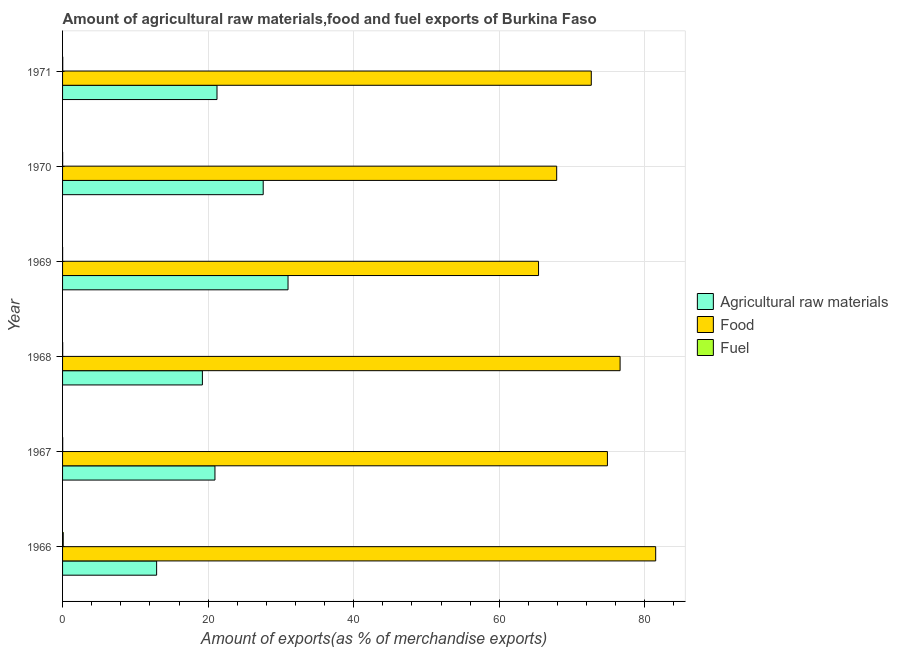How many different coloured bars are there?
Give a very brief answer. 3. How many groups of bars are there?
Your answer should be very brief. 6. How many bars are there on the 6th tick from the top?
Give a very brief answer. 3. How many bars are there on the 4th tick from the bottom?
Make the answer very short. 3. What is the label of the 3rd group of bars from the top?
Provide a succinct answer. 1969. In how many cases, is the number of bars for a given year not equal to the number of legend labels?
Ensure brevity in your answer.  0. What is the percentage of food exports in 1969?
Your response must be concise. 65.39. Across all years, what is the maximum percentage of food exports?
Your answer should be compact. 81.49. Across all years, what is the minimum percentage of fuel exports?
Ensure brevity in your answer.  0.01. In which year was the percentage of raw materials exports maximum?
Your answer should be very brief. 1969. In which year was the percentage of raw materials exports minimum?
Provide a short and direct response. 1966. What is the total percentage of raw materials exports in the graph?
Offer a very short reply. 132.83. What is the difference between the percentage of food exports in 1967 and that in 1969?
Your response must be concise. 9.46. What is the difference between the percentage of fuel exports in 1966 and the percentage of raw materials exports in 1971?
Offer a terse response. -21.13. What is the average percentage of fuel exports per year?
Offer a very short reply. 0.03. In the year 1967, what is the difference between the percentage of fuel exports and percentage of food exports?
Offer a very short reply. -74.84. What is the ratio of the percentage of raw materials exports in 1967 to that in 1968?
Your response must be concise. 1.09. Is the difference between the percentage of fuel exports in 1968 and 1971 greater than the difference between the percentage of food exports in 1968 and 1971?
Offer a very short reply. No. What is the difference between the highest and the second highest percentage of food exports?
Ensure brevity in your answer.  4.89. What is the difference between the highest and the lowest percentage of fuel exports?
Offer a terse response. 0.08. In how many years, is the percentage of fuel exports greater than the average percentage of fuel exports taken over all years?
Make the answer very short. 1. Is the sum of the percentage of fuel exports in 1966 and 1967 greater than the maximum percentage of raw materials exports across all years?
Ensure brevity in your answer.  No. What does the 2nd bar from the top in 1967 represents?
Offer a very short reply. Food. What does the 1st bar from the bottom in 1968 represents?
Provide a succinct answer. Agricultural raw materials. How many years are there in the graph?
Offer a terse response. 6. Does the graph contain any zero values?
Keep it short and to the point. No. Does the graph contain grids?
Offer a very short reply. Yes. Where does the legend appear in the graph?
Offer a terse response. Center right. How many legend labels are there?
Your response must be concise. 3. What is the title of the graph?
Offer a very short reply. Amount of agricultural raw materials,food and fuel exports of Burkina Faso. Does "Ores and metals" appear as one of the legend labels in the graph?
Make the answer very short. No. What is the label or title of the X-axis?
Provide a short and direct response. Amount of exports(as % of merchandise exports). What is the label or title of the Y-axis?
Make the answer very short. Year. What is the Amount of exports(as % of merchandise exports) in Agricultural raw materials in 1966?
Make the answer very short. 12.92. What is the Amount of exports(as % of merchandise exports) of Food in 1966?
Your answer should be compact. 81.49. What is the Amount of exports(as % of merchandise exports) of Fuel in 1966?
Give a very brief answer. 0.09. What is the Amount of exports(as % of merchandise exports) of Agricultural raw materials in 1967?
Keep it short and to the point. 20.94. What is the Amount of exports(as % of merchandise exports) in Food in 1967?
Provide a short and direct response. 74.86. What is the Amount of exports(as % of merchandise exports) of Fuel in 1967?
Provide a succinct answer. 0.02. What is the Amount of exports(as % of merchandise exports) in Agricultural raw materials in 1968?
Ensure brevity in your answer.  19.21. What is the Amount of exports(as % of merchandise exports) in Food in 1968?
Offer a very short reply. 76.6. What is the Amount of exports(as % of merchandise exports) in Fuel in 1968?
Keep it short and to the point. 0.02. What is the Amount of exports(as % of merchandise exports) of Agricultural raw materials in 1969?
Your answer should be very brief. 30.98. What is the Amount of exports(as % of merchandise exports) in Food in 1969?
Provide a succinct answer. 65.39. What is the Amount of exports(as % of merchandise exports) in Fuel in 1969?
Make the answer very short. 0.01. What is the Amount of exports(as % of merchandise exports) of Agricultural raw materials in 1970?
Provide a short and direct response. 27.56. What is the Amount of exports(as % of merchandise exports) of Food in 1970?
Keep it short and to the point. 67.89. What is the Amount of exports(as % of merchandise exports) of Fuel in 1970?
Provide a succinct answer. 0.01. What is the Amount of exports(as % of merchandise exports) of Agricultural raw materials in 1971?
Ensure brevity in your answer.  21.22. What is the Amount of exports(as % of merchandise exports) in Food in 1971?
Give a very brief answer. 72.64. What is the Amount of exports(as % of merchandise exports) in Fuel in 1971?
Make the answer very short. 0.02. Across all years, what is the maximum Amount of exports(as % of merchandise exports) in Agricultural raw materials?
Give a very brief answer. 30.98. Across all years, what is the maximum Amount of exports(as % of merchandise exports) in Food?
Provide a short and direct response. 81.49. Across all years, what is the maximum Amount of exports(as % of merchandise exports) of Fuel?
Keep it short and to the point. 0.09. Across all years, what is the minimum Amount of exports(as % of merchandise exports) of Agricultural raw materials?
Provide a succinct answer. 12.92. Across all years, what is the minimum Amount of exports(as % of merchandise exports) in Food?
Your answer should be very brief. 65.39. Across all years, what is the minimum Amount of exports(as % of merchandise exports) in Fuel?
Offer a very short reply. 0.01. What is the total Amount of exports(as % of merchandise exports) in Agricultural raw materials in the graph?
Your answer should be compact. 132.83. What is the total Amount of exports(as % of merchandise exports) of Food in the graph?
Make the answer very short. 438.86. What is the total Amount of exports(as % of merchandise exports) of Fuel in the graph?
Your answer should be compact. 0.16. What is the difference between the Amount of exports(as % of merchandise exports) in Agricultural raw materials in 1966 and that in 1967?
Offer a terse response. -8.01. What is the difference between the Amount of exports(as % of merchandise exports) in Food in 1966 and that in 1967?
Keep it short and to the point. 6.63. What is the difference between the Amount of exports(as % of merchandise exports) in Fuel in 1966 and that in 1967?
Offer a very short reply. 0.07. What is the difference between the Amount of exports(as % of merchandise exports) of Agricultural raw materials in 1966 and that in 1968?
Give a very brief answer. -6.29. What is the difference between the Amount of exports(as % of merchandise exports) of Food in 1966 and that in 1968?
Give a very brief answer. 4.89. What is the difference between the Amount of exports(as % of merchandise exports) in Fuel in 1966 and that in 1968?
Your answer should be compact. 0.07. What is the difference between the Amount of exports(as % of merchandise exports) in Agricultural raw materials in 1966 and that in 1969?
Your answer should be compact. -18.05. What is the difference between the Amount of exports(as % of merchandise exports) of Food in 1966 and that in 1969?
Provide a succinct answer. 16.09. What is the difference between the Amount of exports(as % of merchandise exports) of Fuel in 1966 and that in 1969?
Make the answer very short. 0.08. What is the difference between the Amount of exports(as % of merchandise exports) in Agricultural raw materials in 1966 and that in 1970?
Provide a short and direct response. -14.64. What is the difference between the Amount of exports(as % of merchandise exports) in Food in 1966 and that in 1970?
Ensure brevity in your answer.  13.6. What is the difference between the Amount of exports(as % of merchandise exports) of Fuel in 1966 and that in 1970?
Give a very brief answer. 0.08. What is the difference between the Amount of exports(as % of merchandise exports) of Agricultural raw materials in 1966 and that in 1971?
Your answer should be very brief. -8.29. What is the difference between the Amount of exports(as % of merchandise exports) in Food in 1966 and that in 1971?
Keep it short and to the point. 8.85. What is the difference between the Amount of exports(as % of merchandise exports) in Fuel in 1966 and that in 1971?
Make the answer very short. 0.07. What is the difference between the Amount of exports(as % of merchandise exports) in Agricultural raw materials in 1967 and that in 1968?
Provide a short and direct response. 1.73. What is the difference between the Amount of exports(as % of merchandise exports) in Food in 1967 and that in 1968?
Offer a very short reply. -1.74. What is the difference between the Amount of exports(as % of merchandise exports) of Agricultural raw materials in 1967 and that in 1969?
Offer a very short reply. -10.04. What is the difference between the Amount of exports(as % of merchandise exports) of Food in 1967 and that in 1969?
Offer a terse response. 9.46. What is the difference between the Amount of exports(as % of merchandise exports) in Fuel in 1967 and that in 1969?
Your answer should be very brief. 0.01. What is the difference between the Amount of exports(as % of merchandise exports) in Agricultural raw materials in 1967 and that in 1970?
Your answer should be compact. -6.63. What is the difference between the Amount of exports(as % of merchandise exports) in Food in 1967 and that in 1970?
Your response must be concise. 6.97. What is the difference between the Amount of exports(as % of merchandise exports) of Fuel in 1967 and that in 1970?
Offer a terse response. 0.01. What is the difference between the Amount of exports(as % of merchandise exports) in Agricultural raw materials in 1967 and that in 1971?
Your response must be concise. -0.28. What is the difference between the Amount of exports(as % of merchandise exports) in Food in 1967 and that in 1971?
Provide a short and direct response. 2.22. What is the difference between the Amount of exports(as % of merchandise exports) of Fuel in 1967 and that in 1971?
Provide a short and direct response. -0.01. What is the difference between the Amount of exports(as % of merchandise exports) in Agricultural raw materials in 1968 and that in 1969?
Provide a succinct answer. -11.77. What is the difference between the Amount of exports(as % of merchandise exports) in Food in 1968 and that in 1969?
Your answer should be very brief. 11.2. What is the difference between the Amount of exports(as % of merchandise exports) in Fuel in 1968 and that in 1969?
Your answer should be compact. 0.01. What is the difference between the Amount of exports(as % of merchandise exports) of Agricultural raw materials in 1968 and that in 1970?
Provide a short and direct response. -8.35. What is the difference between the Amount of exports(as % of merchandise exports) in Food in 1968 and that in 1970?
Your answer should be very brief. 8.71. What is the difference between the Amount of exports(as % of merchandise exports) in Fuel in 1968 and that in 1970?
Your answer should be very brief. 0.01. What is the difference between the Amount of exports(as % of merchandise exports) of Agricultural raw materials in 1968 and that in 1971?
Your answer should be very brief. -2.01. What is the difference between the Amount of exports(as % of merchandise exports) in Food in 1968 and that in 1971?
Offer a very short reply. 3.96. What is the difference between the Amount of exports(as % of merchandise exports) of Fuel in 1968 and that in 1971?
Your answer should be compact. -0.01. What is the difference between the Amount of exports(as % of merchandise exports) in Agricultural raw materials in 1969 and that in 1970?
Your answer should be compact. 3.41. What is the difference between the Amount of exports(as % of merchandise exports) of Food in 1969 and that in 1970?
Give a very brief answer. -2.49. What is the difference between the Amount of exports(as % of merchandise exports) of Fuel in 1969 and that in 1970?
Offer a very short reply. -0. What is the difference between the Amount of exports(as % of merchandise exports) in Agricultural raw materials in 1969 and that in 1971?
Provide a short and direct response. 9.76. What is the difference between the Amount of exports(as % of merchandise exports) of Food in 1969 and that in 1971?
Ensure brevity in your answer.  -7.25. What is the difference between the Amount of exports(as % of merchandise exports) of Fuel in 1969 and that in 1971?
Keep it short and to the point. -0.02. What is the difference between the Amount of exports(as % of merchandise exports) of Agricultural raw materials in 1970 and that in 1971?
Your answer should be compact. 6.35. What is the difference between the Amount of exports(as % of merchandise exports) of Food in 1970 and that in 1971?
Your answer should be compact. -4.75. What is the difference between the Amount of exports(as % of merchandise exports) of Fuel in 1970 and that in 1971?
Make the answer very short. -0.01. What is the difference between the Amount of exports(as % of merchandise exports) in Agricultural raw materials in 1966 and the Amount of exports(as % of merchandise exports) in Food in 1967?
Make the answer very short. -61.93. What is the difference between the Amount of exports(as % of merchandise exports) of Agricultural raw materials in 1966 and the Amount of exports(as % of merchandise exports) of Fuel in 1967?
Offer a terse response. 12.91. What is the difference between the Amount of exports(as % of merchandise exports) in Food in 1966 and the Amount of exports(as % of merchandise exports) in Fuel in 1967?
Offer a very short reply. 81.47. What is the difference between the Amount of exports(as % of merchandise exports) of Agricultural raw materials in 1966 and the Amount of exports(as % of merchandise exports) of Food in 1968?
Give a very brief answer. -63.67. What is the difference between the Amount of exports(as % of merchandise exports) in Agricultural raw materials in 1966 and the Amount of exports(as % of merchandise exports) in Fuel in 1968?
Make the answer very short. 12.91. What is the difference between the Amount of exports(as % of merchandise exports) of Food in 1966 and the Amount of exports(as % of merchandise exports) of Fuel in 1968?
Your answer should be compact. 81.47. What is the difference between the Amount of exports(as % of merchandise exports) of Agricultural raw materials in 1966 and the Amount of exports(as % of merchandise exports) of Food in 1969?
Your response must be concise. -52.47. What is the difference between the Amount of exports(as % of merchandise exports) in Agricultural raw materials in 1966 and the Amount of exports(as % of merchandise exports) in Fuel in 1969?
Keep it short and to the point. 12.92. What is the difference between the Amount of exports(as % of merchandise exports) of Food in 1966 and the Amount of exports(as % of merchandise exports) of Fuel in 1969?
Give a very brief answer. 81.48. What is the difference between the Amount of exports(as % of merchandise exports) in Agricultural raw materials in 1966 and the Amount of exports(as % of merchandise exports) in Food in 1970?
Offer a terse response. -54.96. What is the difference between the Amount of exports(as % of merchandise exports) of Agricultural raw materials in 1966 and the Amount of exports(as % of merchandise exports) of Fuel in 1970?
Ensure brevity in your answer.  12.91. What is the difference between the Amount of exports(as % of merchandise exports) in Food in 1966 and the Amount of exports(as % of merchandise exports) in Fuel in 1970?
Offer a very short reply. 81.48. What is the difference between the Amount of exports(as % of merchandise exports) in Agricultural raw materials in 1966 and the Amount of exports(as % of merchandise exports) in Food in 1971?
Your answer should be compact. -59.71. What is the difference between the Amount of exports(as % of merchandise exports) in Food in 1966 and the Amount of exports(as % of merchandise exports) in Fuel in 1971?
Keep it short and to the point. 81.46. What is the difference between the Amount of exports(as % of merchandise exports) in Agricultural raw materials in 1967 and the Amount of exports(as % of merchandise exports) in Food in 1968?
Your response must be concise. -55.66. What is the difference between the Amount of exports(as % of merchandise exports) of Agricultural raw materials in 1967 and the Amount of exports(as % of merchandise exports) of Fuel in 1968?
Your answer should be very brief. 20.92. What is the difference between the Amount of exports(as % of merchandise exports) in Food in 1967 and the Amount of exports(as % of merchandise exports) in Fuel in 1968?
Your answer should be very brief. 74.84. What is the difference between the Amount of exports(as % of merchandise exports) of Agricultural raw materials in 1967 and the Amount of exports(as % of merchandise exports) of Food in 1969?
Your answer should be very brief. -44.46. What is the difference between the Amount of exports(as % of merchandise exports) in Agricultural raw materials in 1967 and the Amount of exports(as % of merchandise exports) in Fuel in 1969?
Your response must be concise. 20.93. What is the difference between the Amount of exports(as % of merchandise exports) of Food in 1967 and the Amount of exports(as % of merchandise exports) of Fuel in 1969?
Make the answer very short. 74.85. What is the difference between the Amount of exports(as % of merchandise exports) in Agricultural raw materials in 1967 and the Amount of exports(as % of merchandise exports) in Food in 1970?
Give a very brief answer. -46.95. What is the difference between the Amount of exports(as % of merchandise exports) in Agricultural raw materials in 1967 and the Amount of exports(as % of merchandise exports) in Fuel in 1970?
Your answer should be very brief. 20.93. What is the difference between the Amount of exports(as % of merchandise exports) in Food in 1967 and the Amount of exports(as % of merchandise exports) in Fuel in 1970?
Ensure brevity in your answer.  74.85. What is the difference between the Amount of exports(as % of merchandise exports) in Agricultural raw materials in 1967 and the Amount of exports(as % of merchandise exports) in Food in 1971?
Your response must be concise. -51.7. What is the difference between the Amount of exports(as % of merchandise exports) of Agricultural raw materials in 1967 and the Amount of exports(as % of merchandise exports) of Fuel in 1971?
Make the answer very short. 20.91. What is the difference between the Amount of exports(as % of merchandise exports) in Food in 1967 and the Amount of exports(as % of merchandise exports) in Fuel in 1971?
Offer a terse response. 74.83. What is the difference between the Amount of exports(as % of merchandise exports) in Agricultural raw materials in 1968 and the Amount of exports(as % of merchandise exports) in Food in 1969?
Provide a short and direct response. -46.18. What is the difference between the Amount of exports(as % of merchandise exports) in Agricultural raw materials in 1968 and the Amount of exports(as % of merchandise exports) in Fuel in 1969?
Provide a succinct answer. 19.2. What is the difference between the Amount of exports(as % of merchandise exports) in Food in 1968 and the Amount of exports(as % of merchandise exports) in Fuel in 1969?
Keep it short and to the point. 76.59. What is the difference between the Amount of exports(as % of merchandise exports) in Agricultural raw materials in 1968 and the Amount of exports(as % of merchandise exports) in Food in 1970?
Provide a succinct answer. -48.68. What is the difference between the Amount of exports(as % of merchandise exports) of Agricultural raw materials in 1968 and the Amount of exports(as % of merchandise exports) of Fuel in 1970?
Offer a terse response. 19.2. What is the difference between the Amount of exports(as % of merchandise exports) in Food in 1968 and the Amount of exports(as % of merchandise exports) in Fuel in 1970?
Offer a terse response. 76.59. What is the difference between the Amount of exports(as % of merchandise exports) in Agricultural raw materials in 1968 and the Amount of exports(as % of merchandise exports) in Food in 1971?
Make the answer very short. -53.43. What is the difference between the Amount of exports(as % of merchandise exports) of Agricultural raw materials in 1968 and the Amount of exports(as % of merchandise exports) of Fuel in 1971?
Offer a very short reply. 19.19. What is the difference between the Amount of exports(as % of merchandise exports) in Food in 1968 and the Amount of exports(as % of merchandise exports) in Fuel in 1971?
Your answer should be very brief. 76.57. What is the difference between the Amount of exports(as % of merchandise exports) in Agricultural raw materials in 1969 and the Amount of exports(as % of merchandise exports) in Food in 1970?
Provide a short and direct response. -36.91. What is the difference between the Amount of exports(as % of merchandise exports) in Agricultural raw materials in 1969 and the Amount of exports(as % of merchandise exports) in Fuel in 1970?
Ensure brevity in your answer.  30.96. What is the difference between the Amount of exports(as % of merchandise exports) of Food in 1969 and the Amount of exports(as % of merchandise exports) of Fuel in 1970?
Give a very brief answer. 65.38. What is the difference between the Amount of exports(as % of merchandise exports) in Agricultural raw materials in 1969 and the Amount of exports(as % of merchandise exports) in Food in 1971?
Ensure brevity in your answer.  -41.66. What is the difference between the Amount of exports(as % of merchandise exports) of Agricultural raw materials in 1969 and the Amount of exports(as % of merchandise exports) of Fuel in 1971?
Your answer should be very brief. 30.95. What is the difference between the Amount of exports(as % of merchandise exports) of Food in 1969 and the Amount of exports(as % of merchandise exports) of Fuel in 1971?
Offer a very short reply. 65.37. What is the difference between the Amount of exports(as % of merchandise exports) of Agricultural raw materials in 1970 and the Amount of exports(as % of merchandise exports) of Food in 1971?
Give a very brief answer. -45.07. What is the difference between the Amount of exports(as % of merchandise exports) of Agricultural raw materials in 1970 and the Amount of exports(as % of merchandise exports) of Fuel in 1971?
Give a very brief answer. 27.54. What is the difference between the Amount of exports(as % of merchandise exports) of Food in 1970 and the Amount of exports(as % of merchandise exports) of Fuel in 1971?
Give a very brief answer. 67.86. What is the average Amount of exports(as % of merchandise exports) in Agricultural raw materials per year?
Your answer should be compact. 22.14. What is the average Amount of exports(as % of merchandise exports) of Food per year?
Provide a short and direct response. 73.14. What is the average Amount of exports(as % of merchandise exports) of Fuel per year?
Offer a terse response. 0.03. In the year 1966, what is the difference between the Amount of exports(as % of merchandise exports) of Agricultural raw materials and Amount of exports(as % of merchandise exports) of Food?
Offer a terse response. -68.56. In the year 1966, what is the difference between the Amount of exports(as % of merchandise exports) of Agricultural raw materials and Amount of exports(as % of merchandise exports) of Fuel?
Offer a very short reply. 12.83. In the year 1966, what is the difference between the Amount of exports(as % of merchandise exports) in Food and Amount of exports(as % of merchandise exports) in Fuel?
Ensure brevity in your answer.  81.4. In the year 1967, what is the difference between the Amount of exports(as % of merchandise exports) in Agricultural raw materials and Amount of exports(as % of merchandise exports) in Food?
Your answer should be compact. -53.92. In the year 1967, what is the difference between the Amount of exports(as % of merchandise exports) in Agricultural raw materials and Amount of exports(as % of merchandise exports) in Fuel?
Ensure brevity in your answer.  20.92. In the year 1967, what is the difference between the Amount of exports(as % of merchandise exports) of Food and Amount of exports(as % of merchandise exports) of Fuel?
Your response must be concise. 74.84. In the year 1968, what is the difference between the Amount of exports(as % of merchandise exports) in Agricultural raw materials and Amount of exports(as % of merchandise exports) in Food?
Ensure brevity in your answer.  -57.39. In the year 1968, what is the difference between the Amount of exports(as % of merchandise exports) of Agricultural raw materials and Amount of exports(as % of merchandise exports) of Fuel?
Provide a succinct answer. 19.19. In the year 1968, what is the difference between the Amount of exports(as % of merchandise exports) in Food and Amount of exports(as % of merchandise exports) in Fuel?
Provide a succinct answer. 76.58. In the year 1969, what is the difference between the Amount of exports(as % of merchandise exports) in Agricultural raw materials and Amount of exports(as % of merchandise exports) in Food?
Provide a succinct answer. -34.42. In the year 1969, what is the difference between the Amount of exports(as % of merchandise exports) of Agricultural raw materials and Amount of exports(as % of merchandise exports) of Fuel?
Your answer should be compact. 30.97. In the year 1969, what is the difference between the Amount of exports(as % of merchandise exports) in Food and Amount of exports(as % of merchandise exports) in Fuel?
Your answer should be very brief. 65.39. In the year 1970, what is the difference between the Amount of exports(as % of merchandise exports) in Agricultural raw materials and Amount of exports(as % of merchandise exports) in Food?
Give a very brief answer. -40.32. In the year 1970, what is the difference between the Amount of exports(as % of merchandise exports) in Agricultural raw materials and Amount of exports(as % of merchandise exports) in Fuel?
Your answer should be very brief. 27.55. In the year 1970, what is the difference between the Amount of exports(as % of merchandise exports) in Food and Amount of exports(as % of merchandise exports) in Fuel?
Give a very brief answer. 67.87. In the year 1971, what is the difference between the Amount of exports(as % of merchandise exports) of Agricultural raw materials and Amount of exports(as % of merchandise exports) of Food?
Keep it short and to the point. -51.42. In the year 1971, what is the difference between the Amount of exports(as % of merchandise exports) in Agricultural raw materials and Amount of exports(as % of merchandise exports) in Fuel?
Make the answer very short. 21.19. In the year 1971, what is the difference between the Amount of exports(as % of merchandise exports) of Food and Amount of exports(as % of merchandise exports) of Fuel?
Your answer should be compact. 72.61. What is the ratio of the Amount of exports(as % of merchandise exports) in Agricultural raw materials in 1966 to that in 1967?
Offer a terse response. 0.62. What is the ratio of the Amount of exports(as % of merchandise exports) in Food in 1966 to that in 1967?
Give a very brief answer. 1.09. What is the ratio of the Amount of exports(as % of merchandise exports) of Fuel in 1966 to that in 1967?
Keep it short and to the point. 5.58. What is the ratio of the Amount of exports(as % of merchandise exports) in Agricultural raw materials in 1966 to that in 1968?
Ensure brevity in your answer.  0.67. What is the ratio of the Amount of exports(as % of merchandise exports) of Food in 1966 to that in 1968?
Your answer should be compact. 1.06. What is the ratio of the Amount of exports(as % of merchandise exports) of Fuel in 1966 to that in 1968?
Your answer should be compact. 5.57. What is the ratio of the Amount of exports(as % of merchandise exports) of Agricultural raw materials in 1966 to that in 1969?
Your response must be concise. 0.42. What is the ratio of the Amount of exports(as % of merchandise exports) of Food in 1966 to that in 1969?
Your answer should be very brief. 1.25. What is the ratio of the Amount of exports(as % of merchandise exports) of Fuel in 1966 to that in 1969?
Your answer should be compact. 13.82. What is the ratio of the Amount of exports(as % of merchandise exports) of Agricultural raw materials in 1966 to that in 1970?
Offer a very short reply. 0.47. What is the ratio of the Amount of exports(as % of merchandise exports) of Food in 1966 to that in 1970?
Offer a very short reply. 1.2. What is the ratio of the Amount of exports(as % of merchandise exports) in Fuel in 1966 to that in 1970?
Ensure brevity in your answer.  8.25. What is the ratio of the Amount of exports(as % of merchandise exports) in Agricultural raw materials in 1966 to that in 1971?
Make the answer very short. 0.61. What is the ratio of the Amount of exports(as % of merchandise exports) of Food in 1966 to that in 1971?
Offer a terse response. 1.12. What is the ratio of the Amount of exports(as % of merchandise exports) in Fuel in 1966 to that in 1971?
Your answer should be compact. 3.8. What is the ratio of the Amount of exports(as % of merchandise exports) of Agricultural raw materials in 1967 to that in 1968?
Provide a short and direct response. 1.09. What is the ratio of the Amount of exports(as % of merchandise exports) in Food in 1967 to that in 1968?
Offer a terse response. 0.98. What is the ratio of the Amount of exports(as % of merchandise exports) in Agricultural raw materials in 1967 to that in 1969?
Ensure brevity in your answer.  0.68. What is the ratio of the Amount of exports(as % of merchandise exports) of Food in 1967 to that in 1969?
Ensure brevity in your answer.  1.14. What is the ratio of the Amount of exports(as % of merchandise exports) in Fuel in 1967 to that in 1969?
Provide a short and direct response. 2.48. What is the ratio of the Amount of exports(as % of merchandise exports) of Agricultural raw materials in 1967 to that in 1970?
Make the answer very short. 0.76. What is the ratio of the Amount of exports(as % of merchandise exports) in Food in 1967 to that in 1970?
Your response must be concise. 1.1. What is the ratio of the Amount of exports(as % of merchandise exports) of Fuel in 1967 to that in 1970?
Provide a short and direct response. 1.48. What is the ratio of the Amount of exports(as % of merchandise exports) of Agricultural raw materials in 1967 to that in 1971?
Give a very brief answer. 0.99. What is the ratio of the Amount of exports(as % of merchandise exports) in Food in 1967 to that in 1971?
Give a very brief answer. 1.03. What is the ratio of the Amount of exports(as % of merchandise exports) of Fuel in 1967 to that in 1971?
Your response must be concise. 0.68. What is the ratio of the Amount of exports(as % of merchandise exports) in Agricultural raw materials in 1968 to that in 1969?
Offer a very short reply. 0.62. What is the ratio of the Amount of exports(as % of merchandise exports) in Food in 1968 to that in 1969?
Offer a terse response. 1.17. What is the ratio of the Amount of exports(as % of merchandise exports) of Fuel in 1968 to that in 1969?
Provide a short and direct response. 2.48. What is the ratio of the Amount of exports(as % of merchandise exports) in Agricultural raw materials in 1968 to that in 1970?
Offer a very short reply. 0.7. What is the ratio of the Amount of exports(as % of merchandise exports) of Food in 1968 to that in 1970?
Keep it short and to the point. 1.13. What is the ratio of the Amount of exports(as % of merchandise exports) in Fuel in 1968 to that in 1970?
Offer a very short reply. 1.48. What is the ratio of the Amount of exports(as % of merchandise exports) in Agricultural raw materials in 1968 to that in 1971?
Your response must be concise. 0.91. What is the ratio of the Amount of exports(as % of merchandise exports) in Food in 1968 to that in 1971?
Offer a terse response. 1.05. What is the ratio of the Amount of exports(as % of merchandise exports) of Fuel in 1968 to that in 1971?
Keep it short and to the point. 0.68. What is the ratio of the Amount of exports(as % of merchandise exports) of Agricultural raw materials in 1969 to that in 1970?
Provide a short and direct response. 1.12. What is the ratio of the Amount of exports(as % of merchandise exports) in Food in 1969 to that in 1970?
Ensure brevity in your answer.  0.96. What is the ratio of the Amount of exports(as % of merchandise exports) in Fuel in 1969 to that in 1970?
Your answer should be very brief. 0.6. What is the ratio of the Amount of exports(as % of merchandise exports) of Agricultural raw materials in 1969 to that in 1971?
Provide a succinct answer. 1.46. What is the ratio of the Amount of exports(as % of merchandise exports) in Food in 1969 to that in 1971?
Offer a very short reply. 0.9. What is the ratio of the Amount of exports(as % of merchandise exports) of Fuel in 1969 to that in 1971?
Give a very brief answer. 0.28. What is the ratio of the Amount of exports(as % of merchandise exports) in Agricultural raw materials in 1970 to that in 1971?
Keep it short and to the point. 1.3. What is the ratio of the Amount of exports(as % of merchandise exports) in Food in 1970 to that in 1971?
Offer a very short reply. 0.93. What is the ratio of the Amount of exports(as % of merchandise exports) of Fuel in 1970 to that in 1971?
Give a very brief answer. 0.46. What is the difference between the highest and the second highest Amount of exports(as % of merchandise exports) of Agricultural raw materials?
Give a very brief answer. 3.41. What is the difference between the highest and the second highest Amount of exports(as % of merchandise exports) of Food?
Give a very brief answer. 4.89. What is the difference between the highest and the second highest Amount of exports(as % of merchandise exports) of Fuel?
Ensure brevity in your answer.  0.07. What is the difference between the highest and the lowest Amount of exports(as % of merchandise exports) of Agricultural raw materials?
Give a very brief answer. 18.05. What is the difference between the highest and the lowest Amount of exports(as % of merchandise exports) in Food?
Your answer should be compact. 16.09. What is the difference between the highest and the lowest Amount of exports(as % of merchandise exports) of Fuel?
Offer a very short reply. 0.08. 